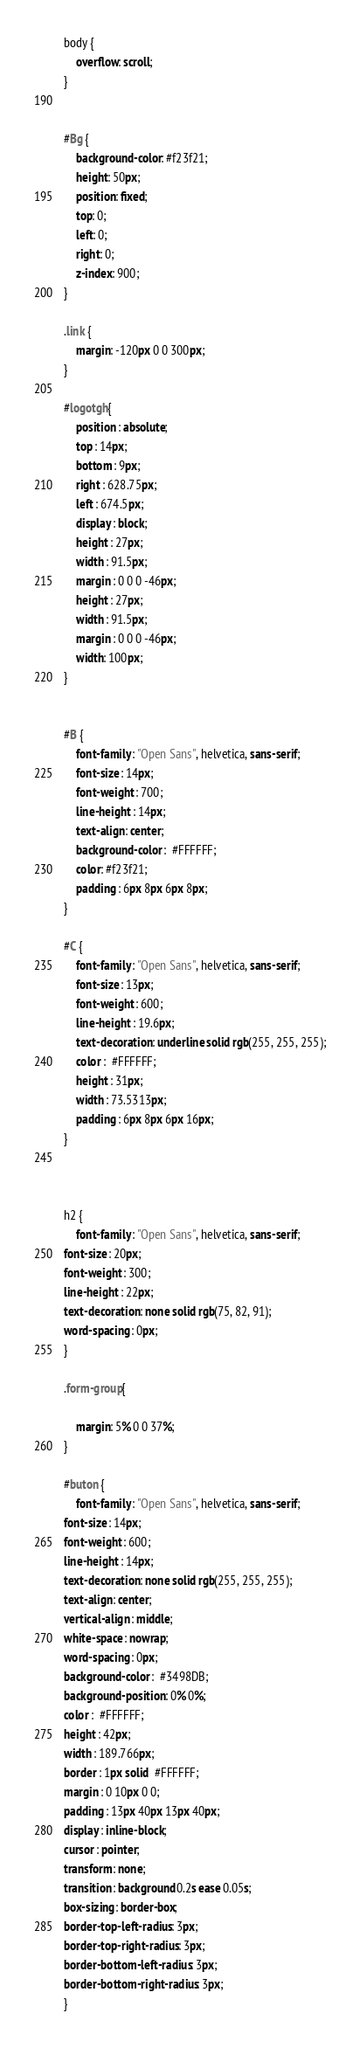Convert code to text. <code><loc_0><loc_0><loc_500><loc_500><_CSS_>body {
    overflow: scroll;
}


#Bg {
    background-color: #f23f21;
    height: 50px;
    position: fixed;
    top: 0;
    left: 0;
    right: 0;
    z-index: 900;
}

.link {
    margin: -120px 0 0 300px;
}

#logotgh{
    position : absolute;
    top : 14px;
    bottom : 9px;
    right : 628.75px;
    left : 674.5px;
    display : block;
    height : 27px;
    width : 91.5px;
    margin : 0 0 0 -46px;
    height : 27px;
    width : 91.5px;
    margin : 0 0 0 -46px;
    width: 100px;
}


#B {
    font-family : "Open Sans", helvetica, sans-serif;
    font-size : 14px;
    font-weight : 700;
    line-height : 14px;
    text-align : center;
    background-color :  #FFFFFF;
    color: #f23f21;
    padding : 6px 8px 6px 8px;
}

#C {
    font-family : "Open Sans", helvetica, sans-serif;
    font-size : 13px;
    font-weight : 600;
    line-height : 19.6px;
    text-decoration : underline solid rgb(255, 255, 255);
    color :  #FFFFFF;
    height : 31px;
    width : 73.5313px;
    padding : 6px 8px 6px 16px;
}



h2 {
    font-family : "Open Sans", helvetica, sans-serif;
font-size : 20px;
font-weight : 300;
line-height : 22px;
text-decoration : none solid rgb(75, 82, 91);
word-spacing : 0px;
}

.form-group{
  
    margin: 5% 0 0 37%;
}

#buton {
    font-family : "Open Sans", helvetica, sans-serif;
font-size : 14px;
font-weight : 600;
line-height : 14px;
text-decoration : none solid rgb(255, 255, 255);
text-align : center;
vertical-align : middle;
white-space : nowrap;
word-spacing : 0px;
background-color :  #3498DB;
background-position : 0% 0%;
color :  #FFFFFF;
height : 42px;
width : 189.766px;
border : 1px solid  #FFFFFF;
margin : 0 10px 0 0;
padding : 13px 40px 13px 40px;
display : inline-block;
cursor : pointer;
transform : none;
transition : background 0.2s ease 0.05s;
box-sizing : border-box;
border-top-left-radius : 3px;
border-top-right-radius : 3px;
border-bottom-left-radius : 3px;
border-bottom-right-radius : 3px;
}

</code> 